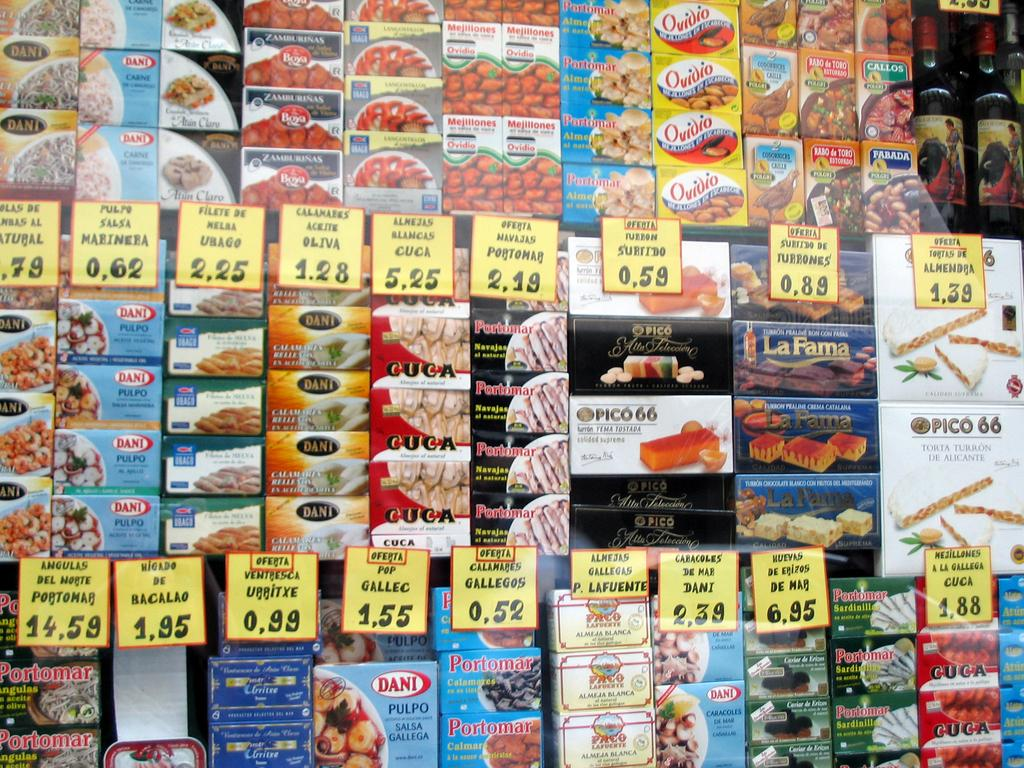<image>
Render a clear and concise summary of the photo. Various snacks on grocery shelves with the most expensive snack costing 14,59 